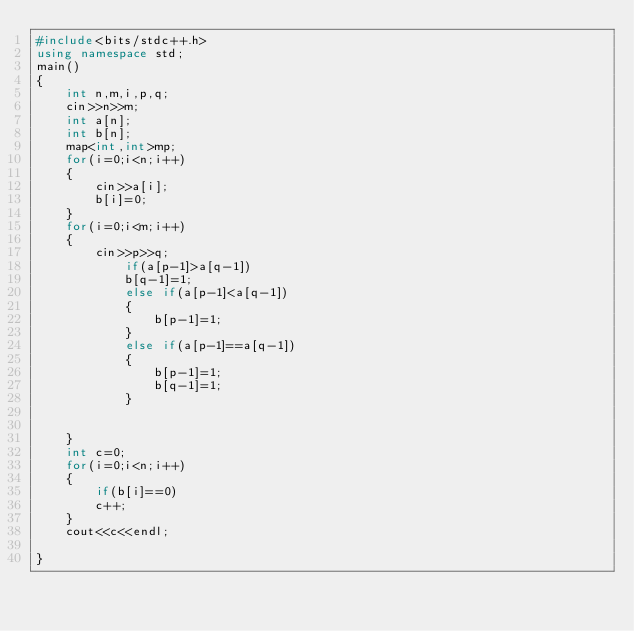Convert code to text. <code><loc_0><loc_0><loc_500><loc_500><_C++_>#include<bits/stdc++.h>
using namespace std;
main()
{
	int n,m,i,p,q;
	cin>>n>>m;
	int a[n];
	int b[n];
	map<int,int>mp;
	for(i=0;i<n;i++)
	{
		cin>>a[i];
		b[i]=0;
	}
	for(i=0;i<m;i++)
	{
		cin>>p>>q;
			if(a[p-1]>a[q-1])
			b[q-1]=1;
			else if(a[p-1]<a[q-1])
			{
				b[p-1]=1;
			}
			else if(a[p-1]==a[q-1])
			{
				b[p-1]=1;
				b[q-1]=1;
			}
		
		
	}
	int c=0;
	for(i=0;i<n;i++)
	{
		if(b[i]==0)
		c++;
	}
	cout<<c<<endl;
 
}</code> 